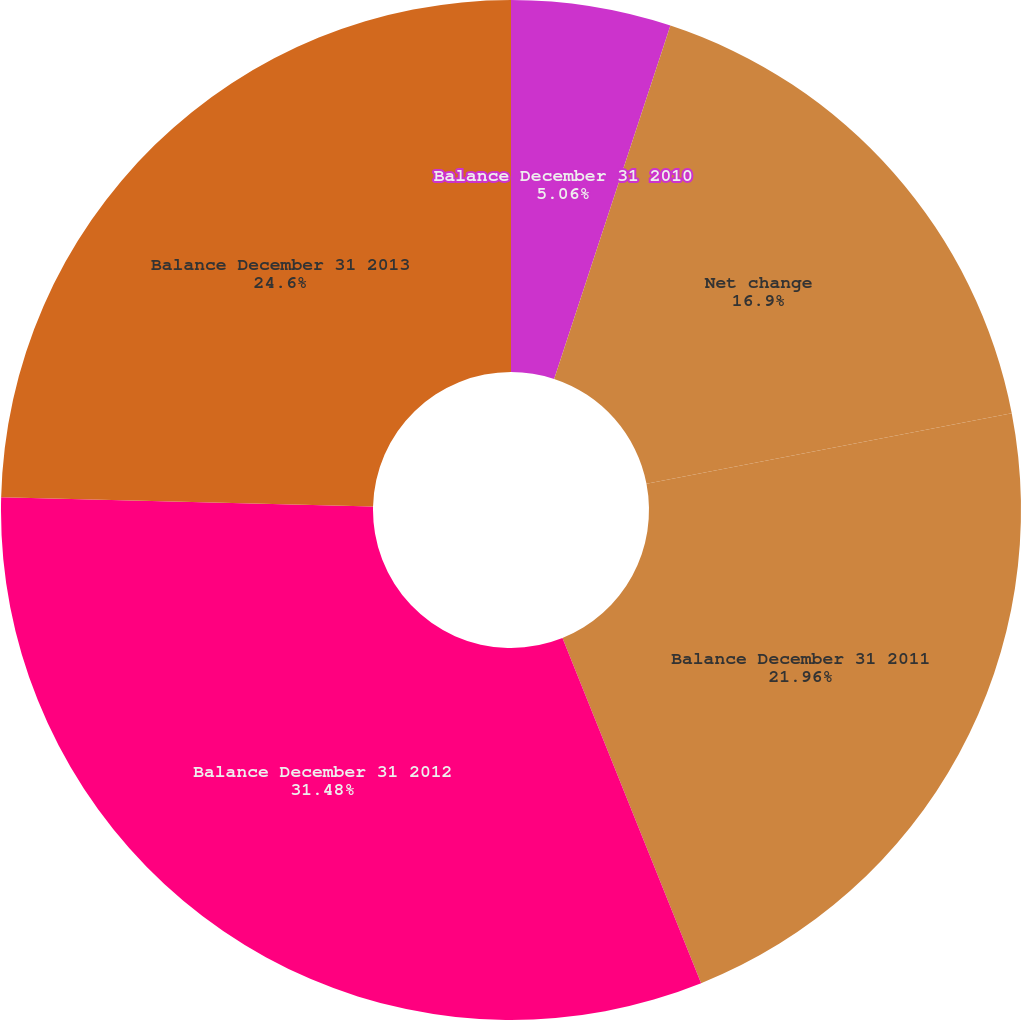Convert chart. <chart><loc_0><loc_0><loc_500><loc_500><pie_chart><fcel>Balance December 31 2010<fcel>Net change<fcel>Balance December 31 2011<fcel>Balance December 31 2012<fcel>Balance December 31 2013<nl><fcel>5.06%<fcel>16.9%<fcel>21.96%<fcel>31.48%<fcel>24.6%<nl></chart> 